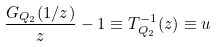Convert formula to latex. <formula><loc_0><loc_0><loc_500><loc_500>\frac { G _ { Q _ { 2 } } ( 1 / z ) } { z } - 1 \equiv T _ { Q _ { 2 } } ^ { - 1 } ( z ) \equiv u</formula> 